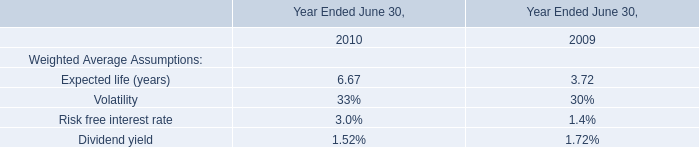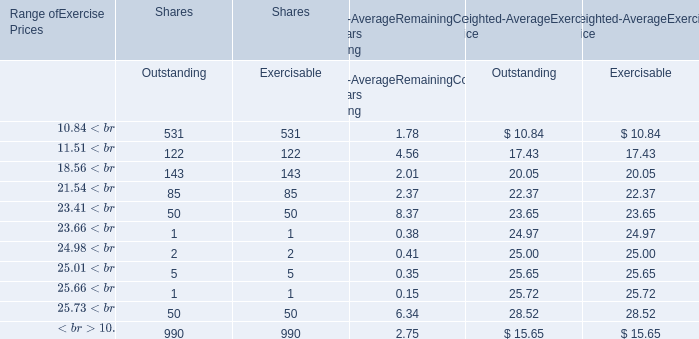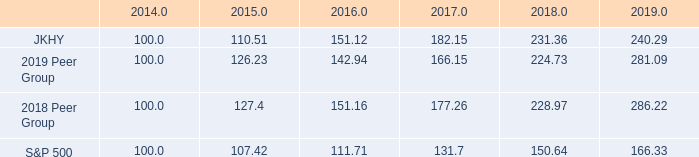what was the percentage growth of the 5 year- cumulative total return for the 2018 peer group from 2016 to 2017 
Computations: ((177.26 - 151.16) - 151.16)
Answer: -125.06. 